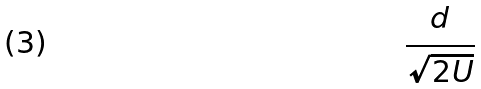<formula> <loc_0><loc_0><loc_500><loc_500>\frac { d } { \sqrt { 2 U } }</formula> 